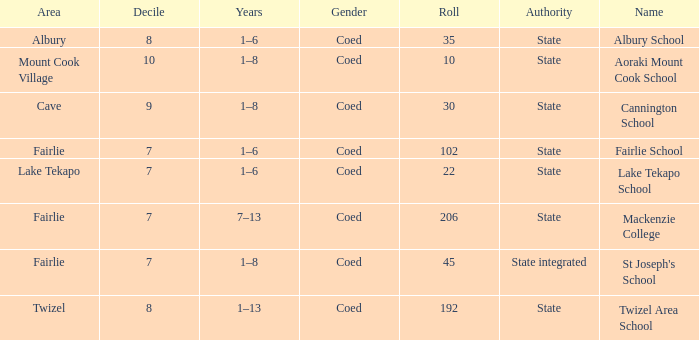What area is named Mackenzie college? Fairlie. 